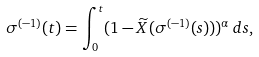<formula> <loc_0><loc_0><loc_500><loc_500>\sigma ^ { ( - 1 ) } ( t ) = \int _ { 0 } ^ { t } ( 1 - \widetilde { X } ( \sigma ^ { ( - 1 ) } ( s ) ) ) ^ { \alpha } \, d s ,</formula> 